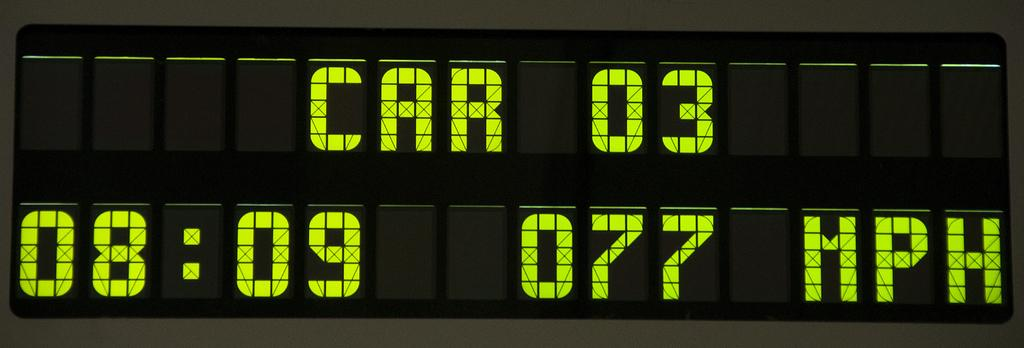<image>
Summarize the visual content of the image. A sign that reads 8:09 as the time in green neon numbers. 